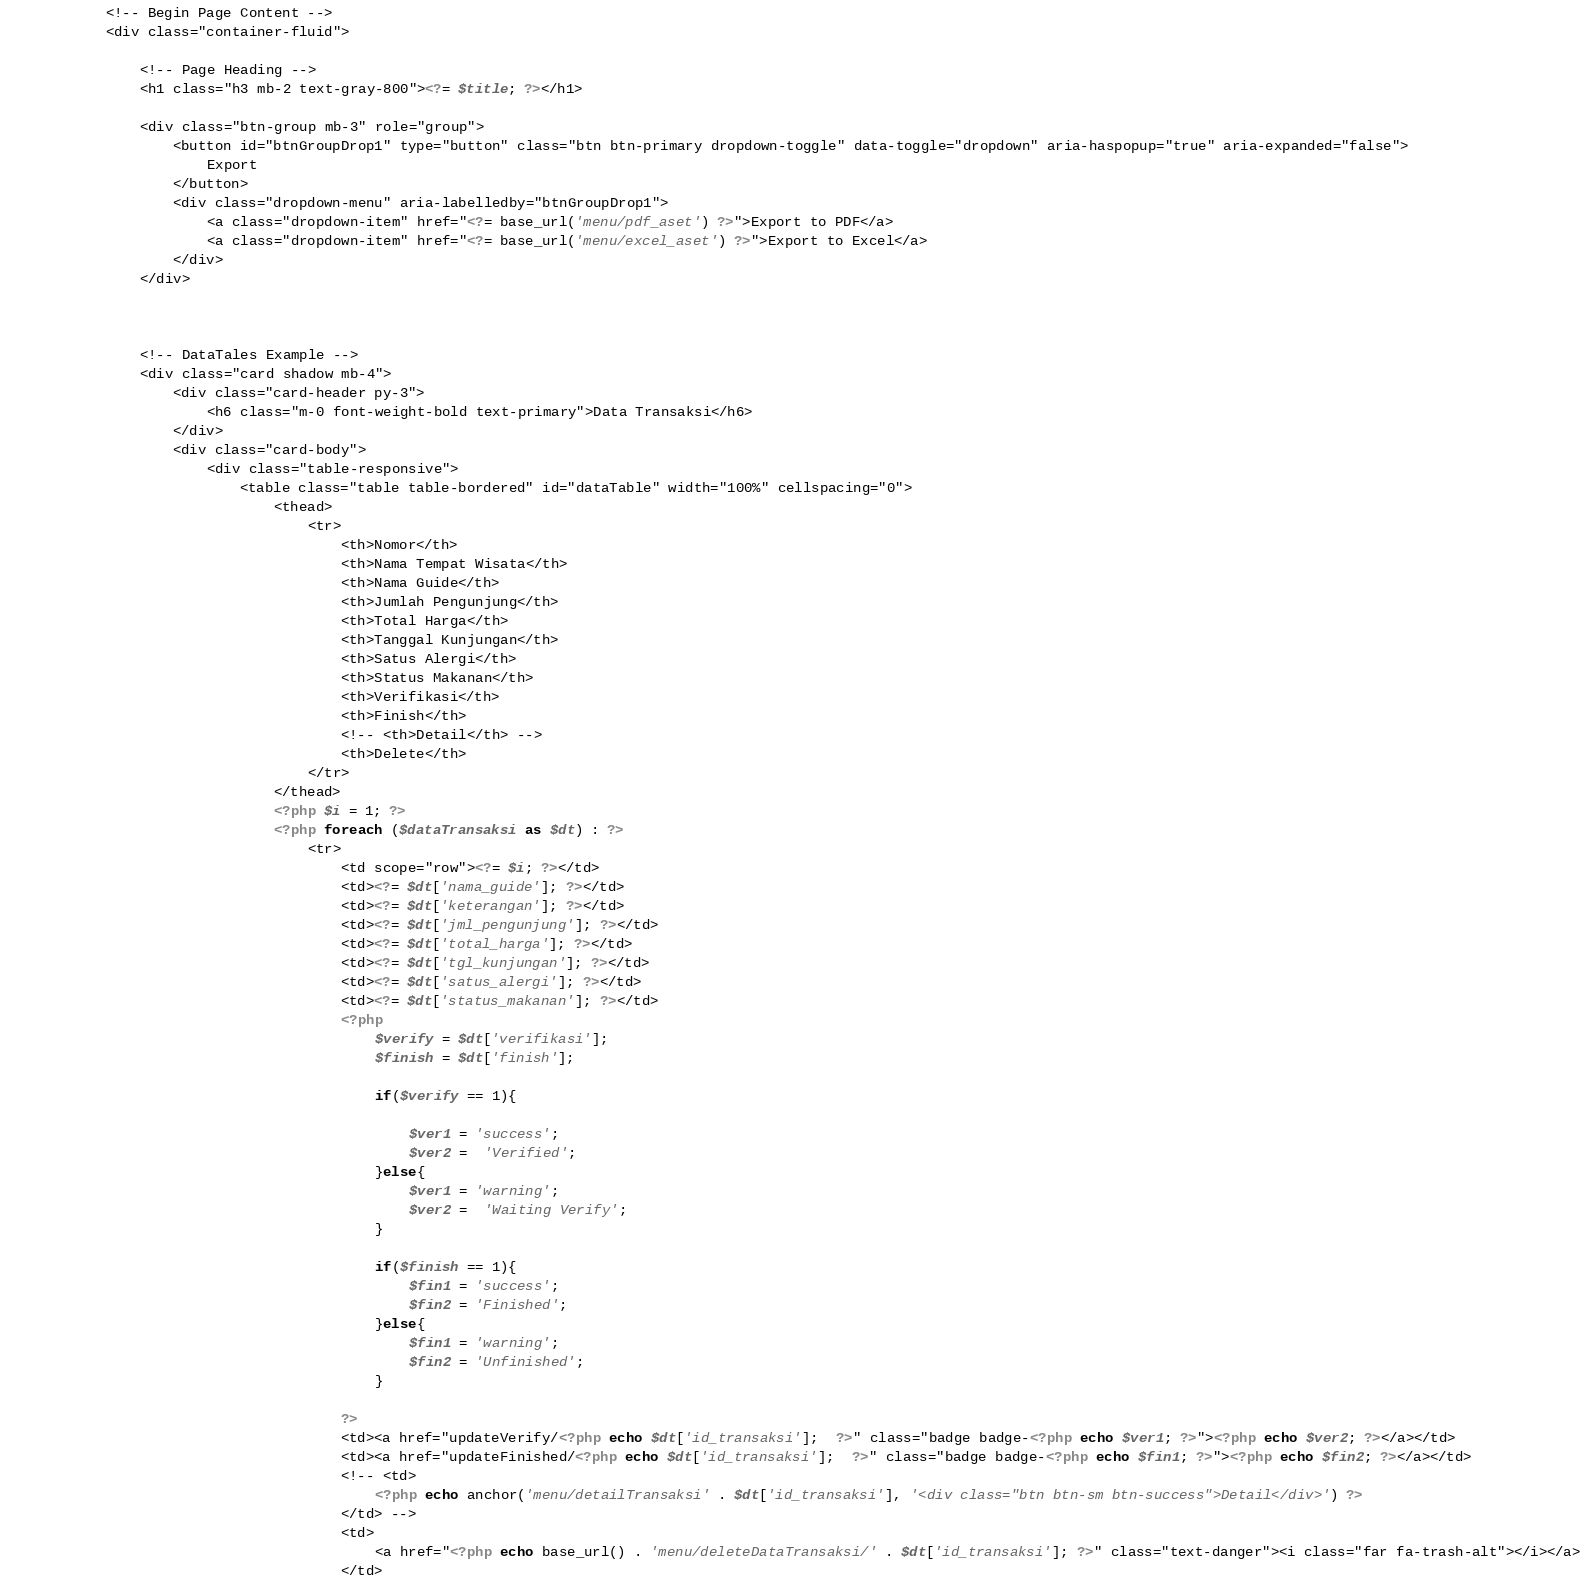Convert code to text. <code><loc_0><loc_0><loc_500><loc_500><_PHP_>            <!-- Begin Page Content -->
            <div class="container-fluid">

                <!-- Page Heading -->
                <h1 class="h3 mb-2 text-gray-800"><?= $title; ?></h1>

                <div class="btn-group mb-3" role="group">
                    <button id="btnGroupDrop1" type="button" class="btn btn-primary dropdown-toggle" data-toggle="dropdown" aria-haspopup="true" aria-expanded="false">
                        Export
                    </button>
                    <div class="dropdown-menu" aria-labelledby="btnGroupDrop1">
                        <a class="dropdown-item" href="<?= base_url('menu/pdf_aset') ?>">Export to PDF</a>
                        <a class="dropdown-item" href="<?= base_url('menu/excel_aset') ?>">Export to Excel</a>
                    </div>
                </div>



                <!-- DataTales Example -->
                <div class="card shadow mb-4">
                    <div class="card-header py-3">
                        <h6 class="m-0 font-weight-bold text-primary">Data Transaksi</h6>
                    </div>
                    <div class="card-body">
                        <div class="table-responsive">
                            <table class="table table-bordered" id="dataTable" width="100%" cellspacing="0">
                                <thead>
                                    <tr>
                                        <th>Nomor</th>
                                        <th>Nama Tempat Wisata</th>
                                        <th>Nama Guide</th>
                                        <th>Jumlah Pengunjung</th>
                                        <th>Total Harga</th>
                                        <th>Tanggal Kunjungan</th>
                                        <th>Satus Alergi</th>
                                        <th>Status Makanan</th>
                                        <th>Verifikasi</th>
                                        <th>Finish</th>
                                        <!-- <th>Detail</th> -->
                                        <th>Delete</th>
                                    </tr>
                                </thead>
                                <?php $i = 1; ?>
                                <?php foreach ($dataTransaksi as $dt) : ?>
                                    <tr>
                                        <td scope="row"><?= $i; ?></td>
                                        <td><?= $dt['nama_guide']; ?></td>
                                        <td><?= $dt['keterangan']; ?></td>
                                        <td><?= $dt['jml_pengunjung']; ?></td>
                                        <td><?= $dt['total_harga']; ?></td>
                                        <td><?= $dt['tgl_kunjungan']; ?></td>
                                        <td><?= $dt['satus_alergi']; ?></td>
                                        <td><?= $dt['status_makanan']; ?></td>
                                        <?php
                                            $verify = $dt['verifikasi'];
                                            $finish = $dt['finish'];

                                            if($verify == 1){

                                                $ver1 = 'success';
                                                $ver2 =  'Verified';
                                            }else{
                                                $ver1 = 'warning';
                                                $ver2 =  'Waiting Verify';
                                            }

                                            if($finish == 1){
                                                $fin1 = 'success';
                                                $fin2 = 'Finished';
                                            }else{
                                                $fin1 = 'warning';
                                                $fin2 = 'Unfinished';
                                            }

                                        ?>
                                        <td><a href="updateVerify/<?php echo $dt['id_transaksi'];  ?>" class="badge badge-<?php echo $ver1; ?>"><?php echo $ver2; ?></a></td>
                                        <td><a href="updateFinished/<?php echo $dt['id_transaksi'];  ?>" class="badge badge-<?php echo $fin1; ?>"><?php echo $fin2; ?></a></td>
                                        <!-- <td>
                                            <?php echo anchor('menu/detailTransaksi' . $dt['id_transaksi'], '<div class="btn btn-sm btn-success">Detail</div>') ?>
                                        </td> -->
                                        <td>
                                            <a href="<?php echo base_url() . 'menu/deleteDataTransaksi/' . $dt['id_transaksi']; ?>" class="text-danger"><i class="far fa-trash-alt"></i></a>
                                        </td></code> 